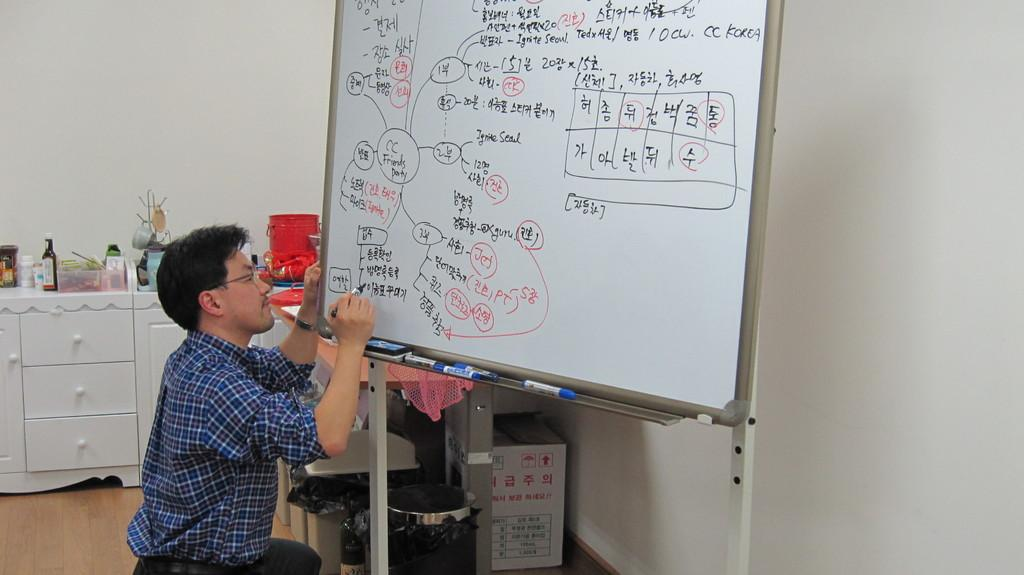<image>
Present a compact description of the photo's key features. A man is kneeling down and writing on a white board with CC Korea written in the top right corner. 